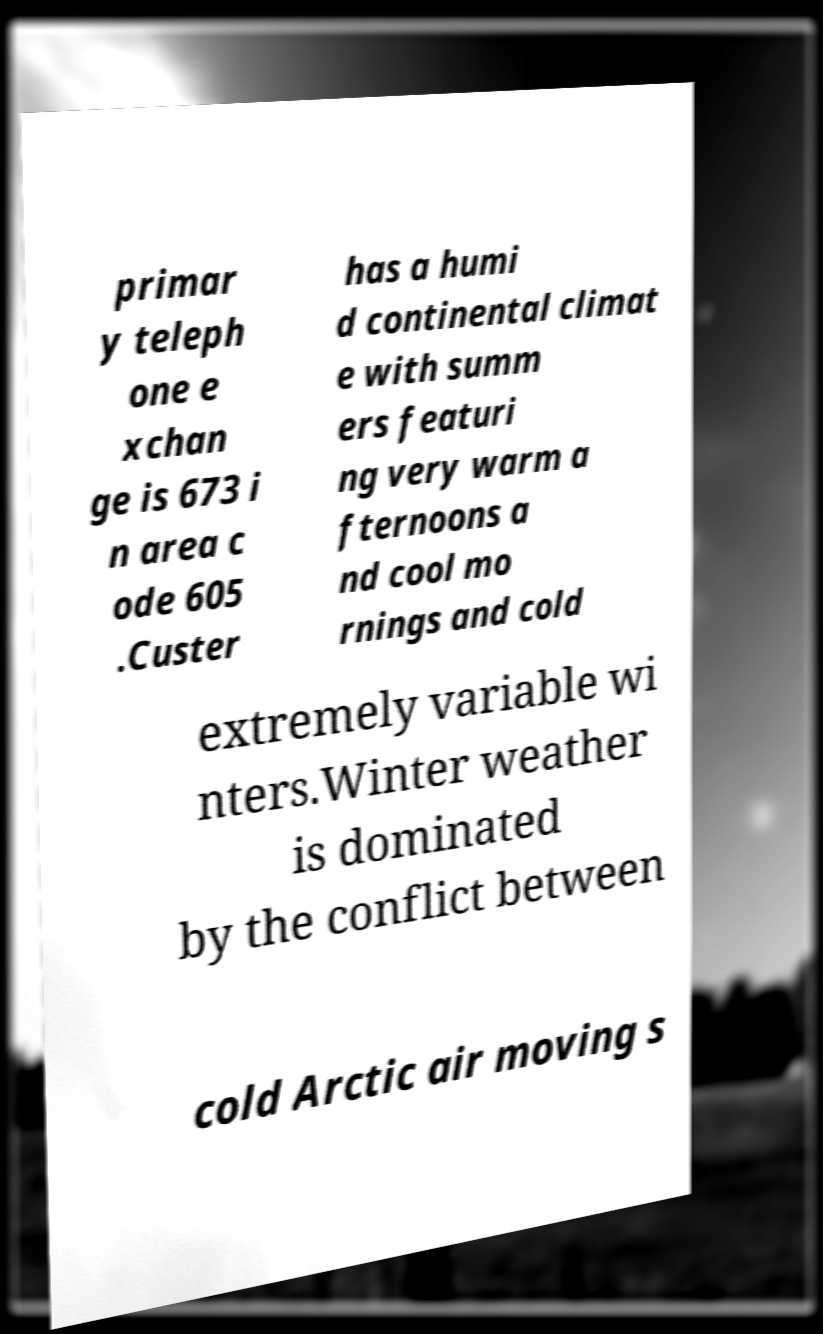I need the written content from this picture converted into text. Can you do that? primar y teleph one e xchan ge is 673 i n area c ode 605 .Custer has a humi d continental climat e with summ ers featuri ng very warm a fternoons a nd cool mo rnings and cold extremely variable wi nters.Winter weather is dominated by the conflict between cold Arctic air moving s 